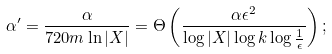Convert formula to latex. <formula><loc_0><loc_0><loc_500><loc_500>\alpha ^ { \prime } = \frac { \alpha } { 7 2 0 m \ln | X | } = \Theta \left ( \frac { \alpha \epsilon ^ { 2 } } { \log | X | \log k \log \frac { 1 } { \epsilon } } \right ) ;</formula> 